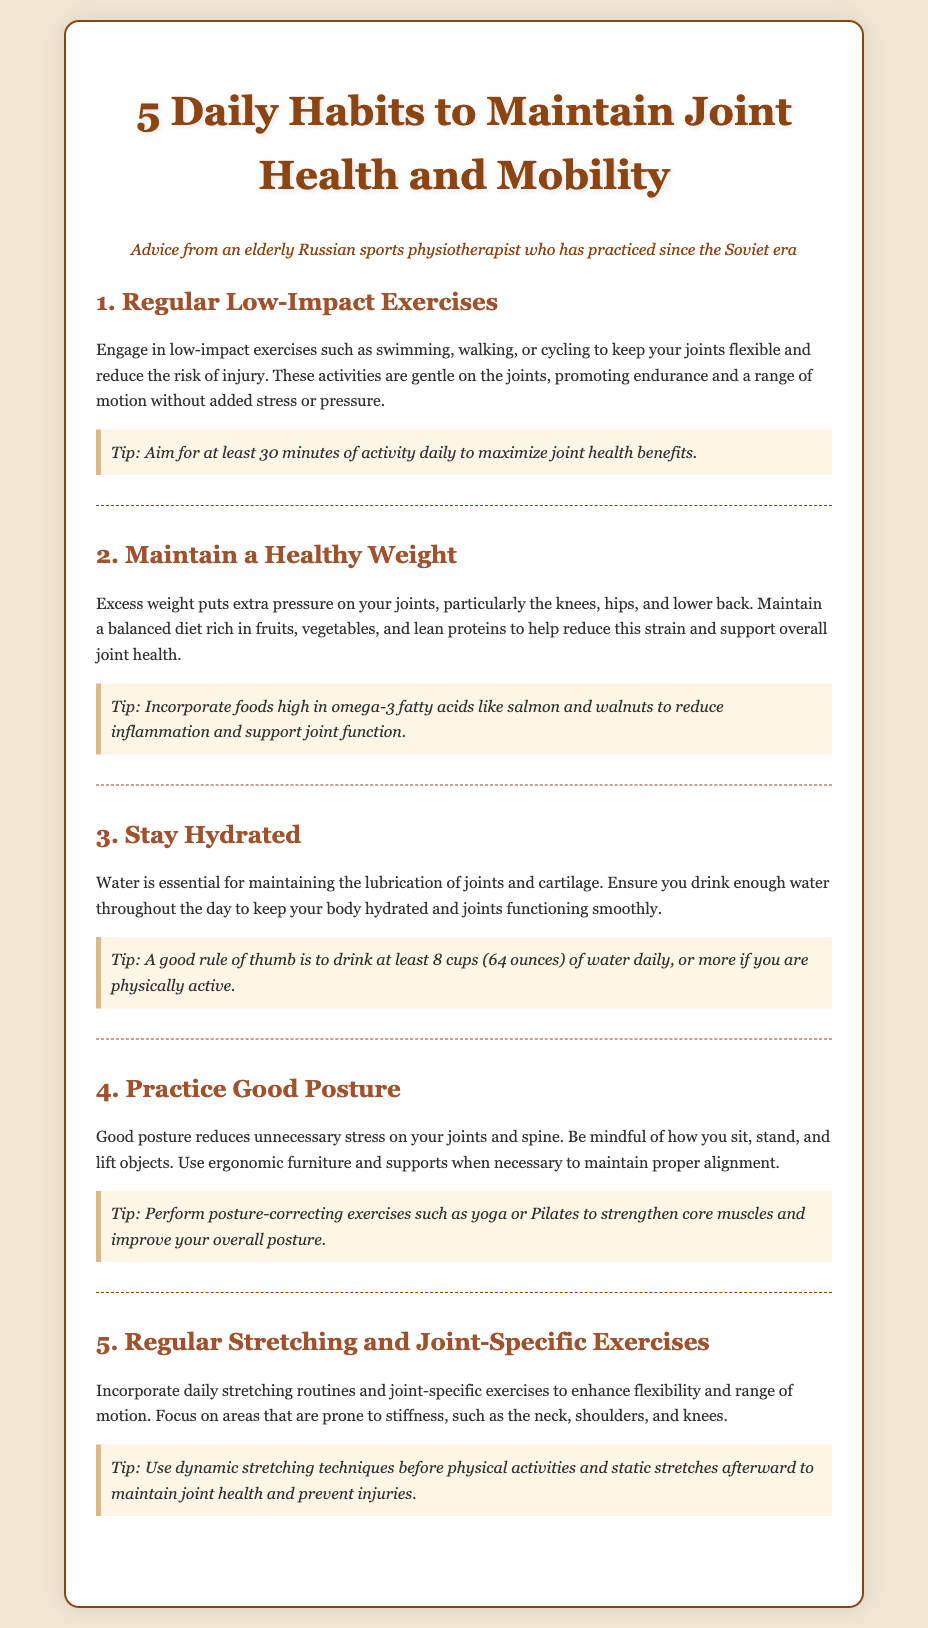What is the title of the infographic? The title is stated at the top of the document, highlighting the focus on daily habits for joint health.
Answer: 5 Daily Habits to Maintain Joint Health and Mobility How many habits are listed in the document? The document outlines a total number of habits that are directly mentioned in the title.
Answer: 5 What type of exercises should be prioritized for joint health? The document specifies the recommended exercise type that minimizes stress on joints.
Answer: Low-impact exercises What is a suggested daily water intake mentioned in the document? The document provides a guideline regarding the amount of water one should drink daily.
Answer: 8 cups (64 ounces) What should you focus on in joint-specific exercises? The document emphasizes the specific areas that require attention during joint-specific exercises.
Answer: Areas that are prone to stiffness Which exercise types are recommended for improving posture? The document suggests specific exercise practices that contribute to enhancing posture.
Answer: Yoga or Pilates What dietary element is advised to help reduce inflammation? The document mentions a type of food known for its inflammatory properties beneficial for joints.
Answer: Omega-3 fatty acids What is the primary goal of regular stretching routines according to the document? The document explains the primary benefit of incorporating stretching into daily routines.
Answer: Enhance flexibility and range of motion 